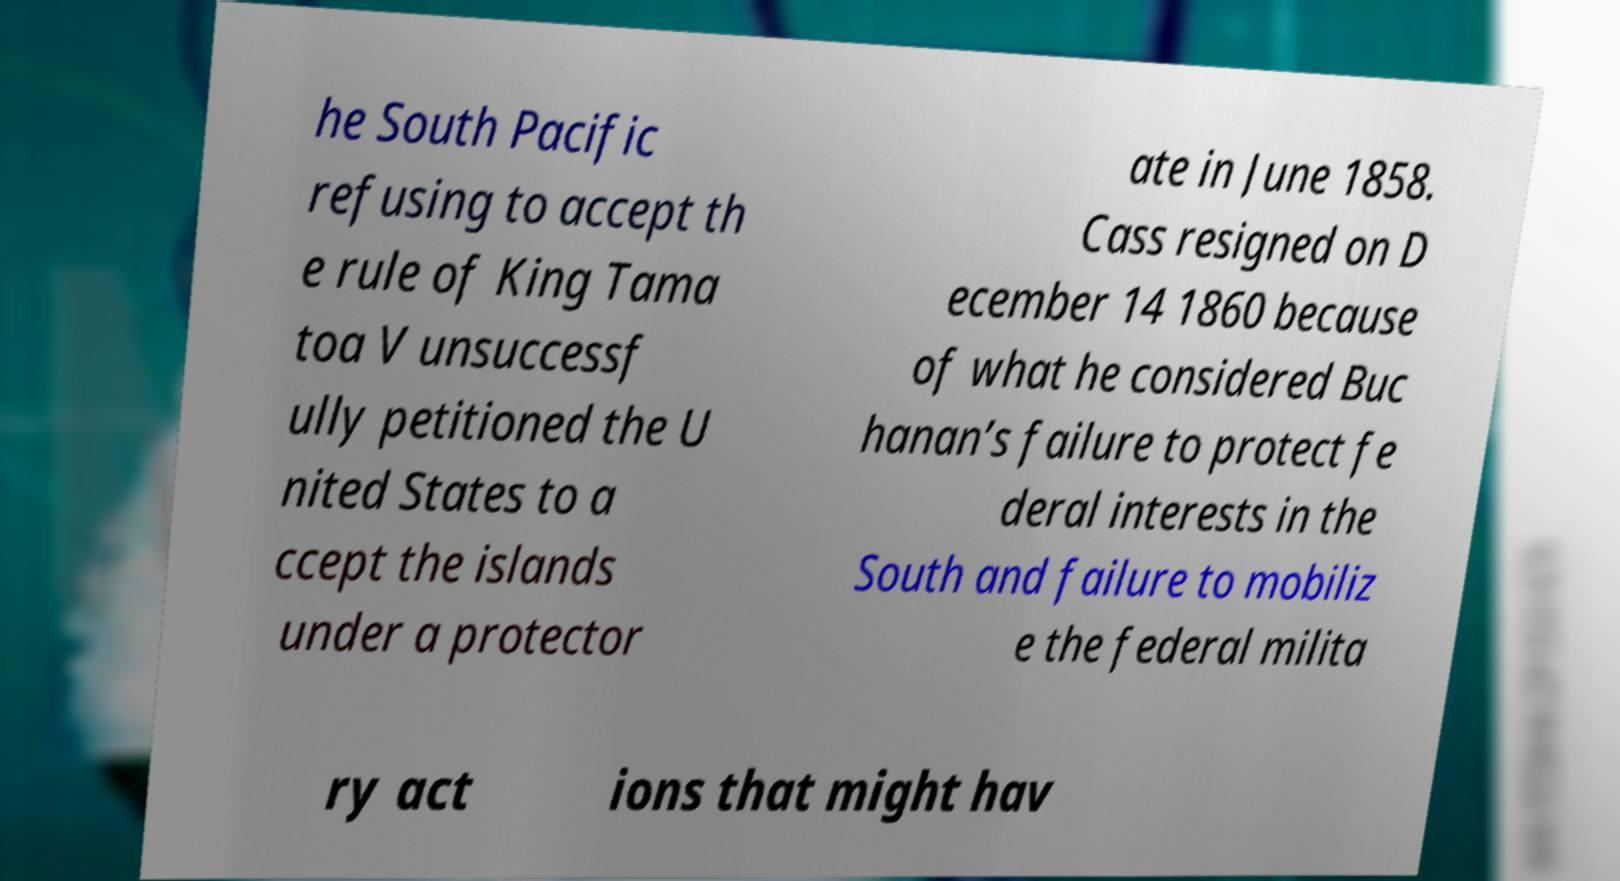Please identify and transcribe the text found in this image. he South Pacific refusing to accept th e rule of King Tama toa V unsuccessf ully petitioned the U nited States to a ccept the islands under a protector ate in June 1858. Cass resigned on D ecember 14 1860 because of what he considered Buc hanan’s failure to protect fe deral interests in the South and failure to mobiliz e the federal milita ry act ions that might hav 